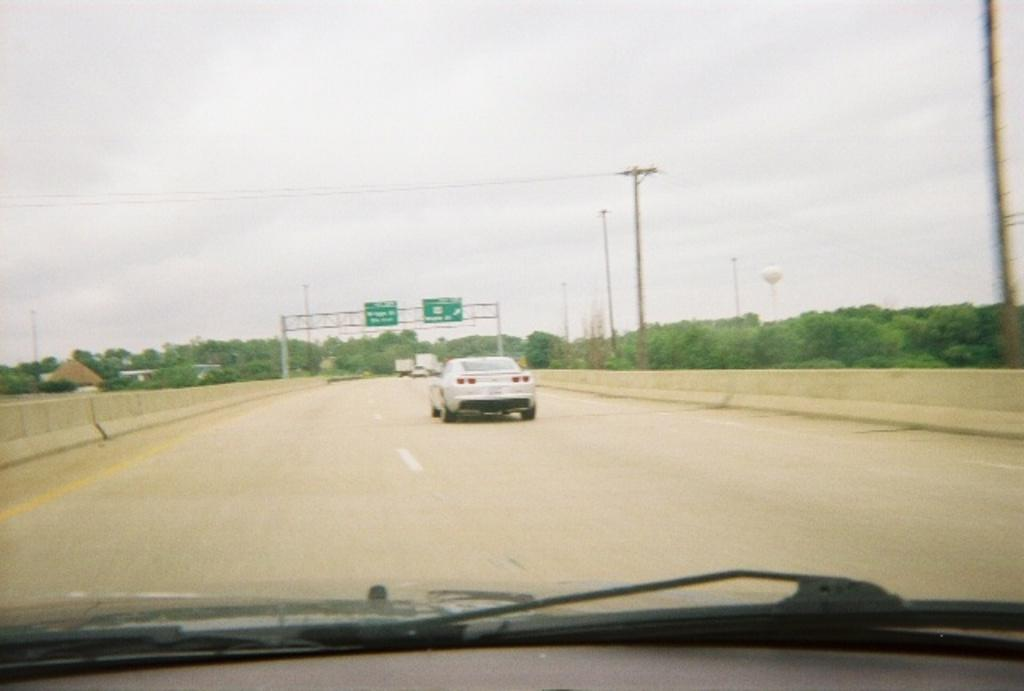What is the main subject of the image? The main subject of the image is a car on the road. What can be seen on both sides of the road in the image? There are trees and poles on both sides of the road in the image. What is visible in the sky in the image? Many clouds are visible in the sky in the image. How many teeth can be seen in the image? There are no teeth visible in the image. 